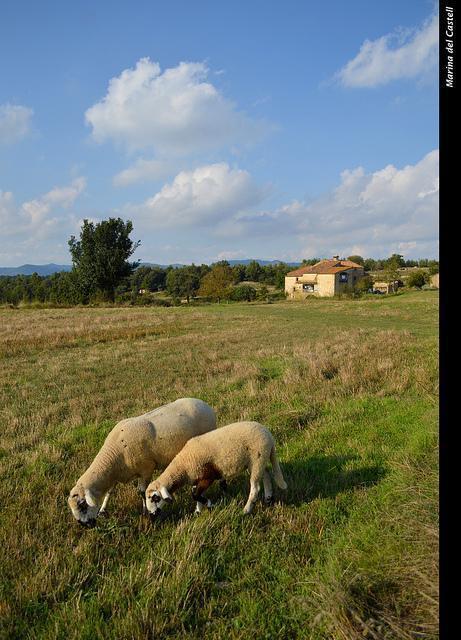How many animals do you see?
Give a very brief answer. 2. How many sheep are there?
Give a very brief answer. 2. How many sheep are visible?
Give a very brief answer. 2. How many people are holding phone?
Give a very brief answer. 0. 